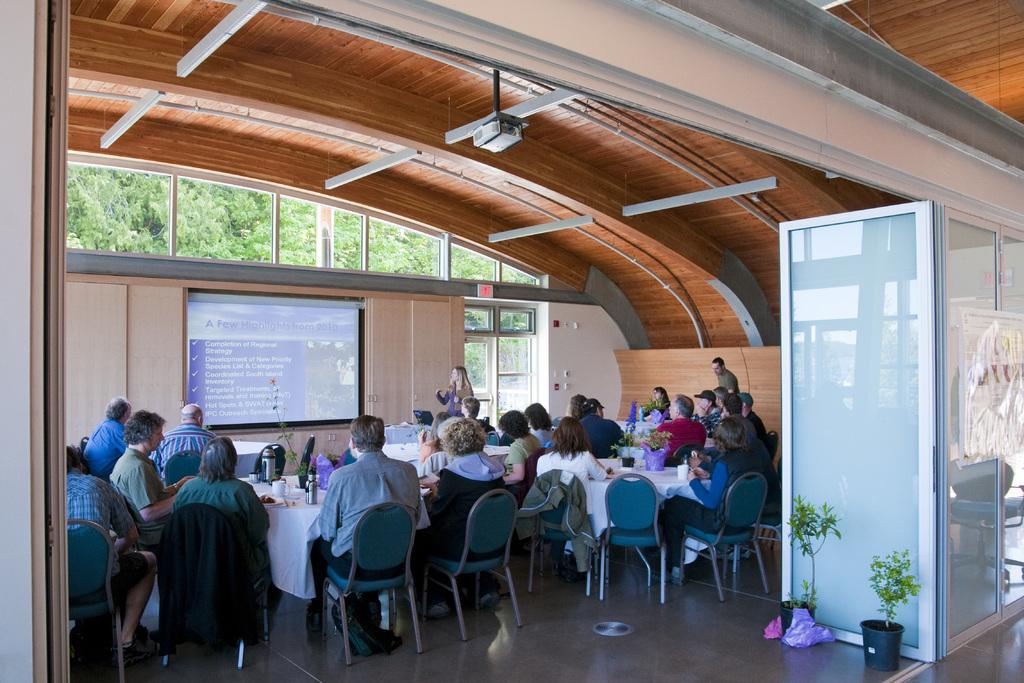What type of vegetation can be seen in the image? There are trees in the image. What type of structure is visible in the image? There is a wall in the image. What architectural feature is present in the wall? There is a window in the image. What is the purpose of the screen in the image? The screen's purpose is not specified, but it is visible in the image. What type of containers are present in the image? There are pots in the image. What are the people in the image doing? The people are sitting on chairs in the image. What type of furniture is present in the image? There is a table in the image. What type of tableware is present on the table? There are glasses on the table. What type of beverage containers are present on the table? There are bottles on the table. What type of fang can be seen in the image? There is no fang present in the image. How does the chalk contribute to the image? There is no chalk present in the image. 